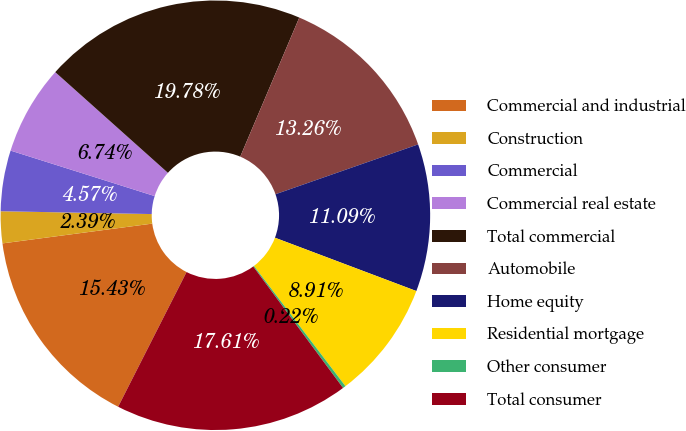Convert chart to OTSL. <chart><loc_0><loc_0><loc_500><loc_500><pie_chart><fcel>Commercial and industrial<fcel>Construction<fcel>Commercial<fcel>Commercial real estate<fcel>Total commercial<fcel>Automobile<fcel>Home equity<fcel>Residential mortgage<fcel>Other consumer<fcel>Total consumer<nl><fcel>15.43%<fcel>2.39%<fcel>4.57%<fcel>6.74%<fcel>19.78%<fcel>13.26%<fcel>11.09%<fcel>8.91%<fcel>0.22%<fcel>17.61%<nl></chart> 